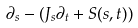Convert formula to latex. <formula><loc_0><loc_0><loc_500><loc_500>\partial _ { s } - ( J _ { s } \partial _ { t } + S ( s , t ) )</formula> 